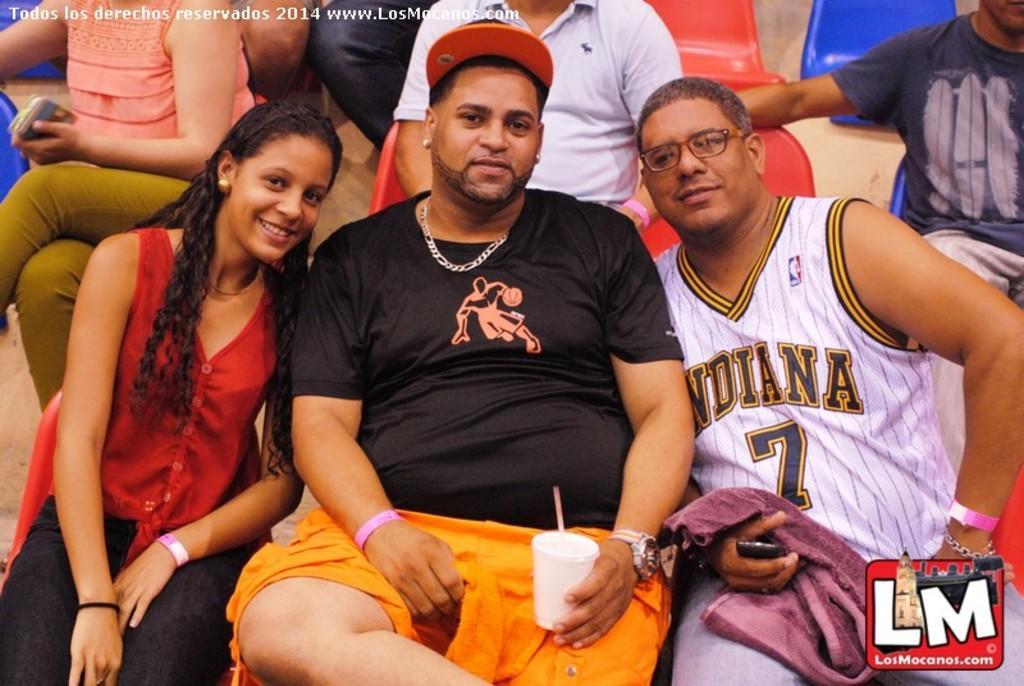How would you summarize this image in a sentence or two? In this picture we can observe three members sitting in the red color chairs. Two of them are men and the other is a woman. One of them is wearing a cap and holding a cup in his hands and the other is wearing spectacles. In the background there are some people in the chairs. We can observe men and women. There is a watermark on the left side. 